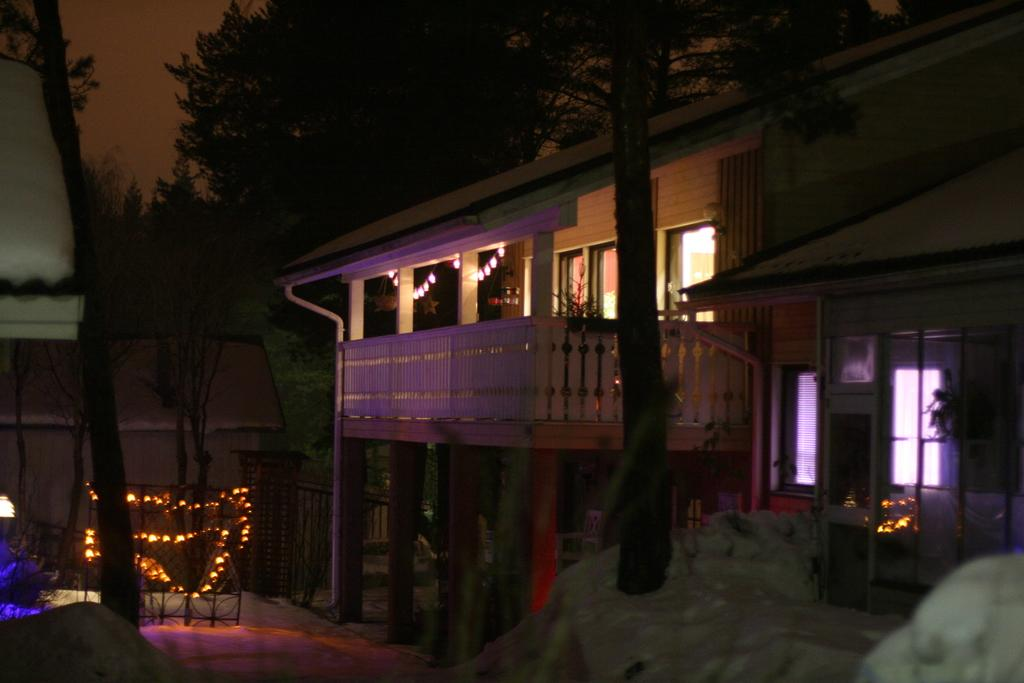What type of structure is in the image? There is a house in the image. What features can be seen on the house? The house has a roof, windows, and a door. Are there any natural elements in the image? Yes, there is a group of trees in the image, and the bark of a tree is visible. What is the source of illumination in the image? There are lights visible in the image, both on the house and on a barricade. What can be seen in the sky in the image? The sky is visible in the image. What type of polish is being applied to the sheep in the image? There are no sheep present in the image, so no polish is being applied. 